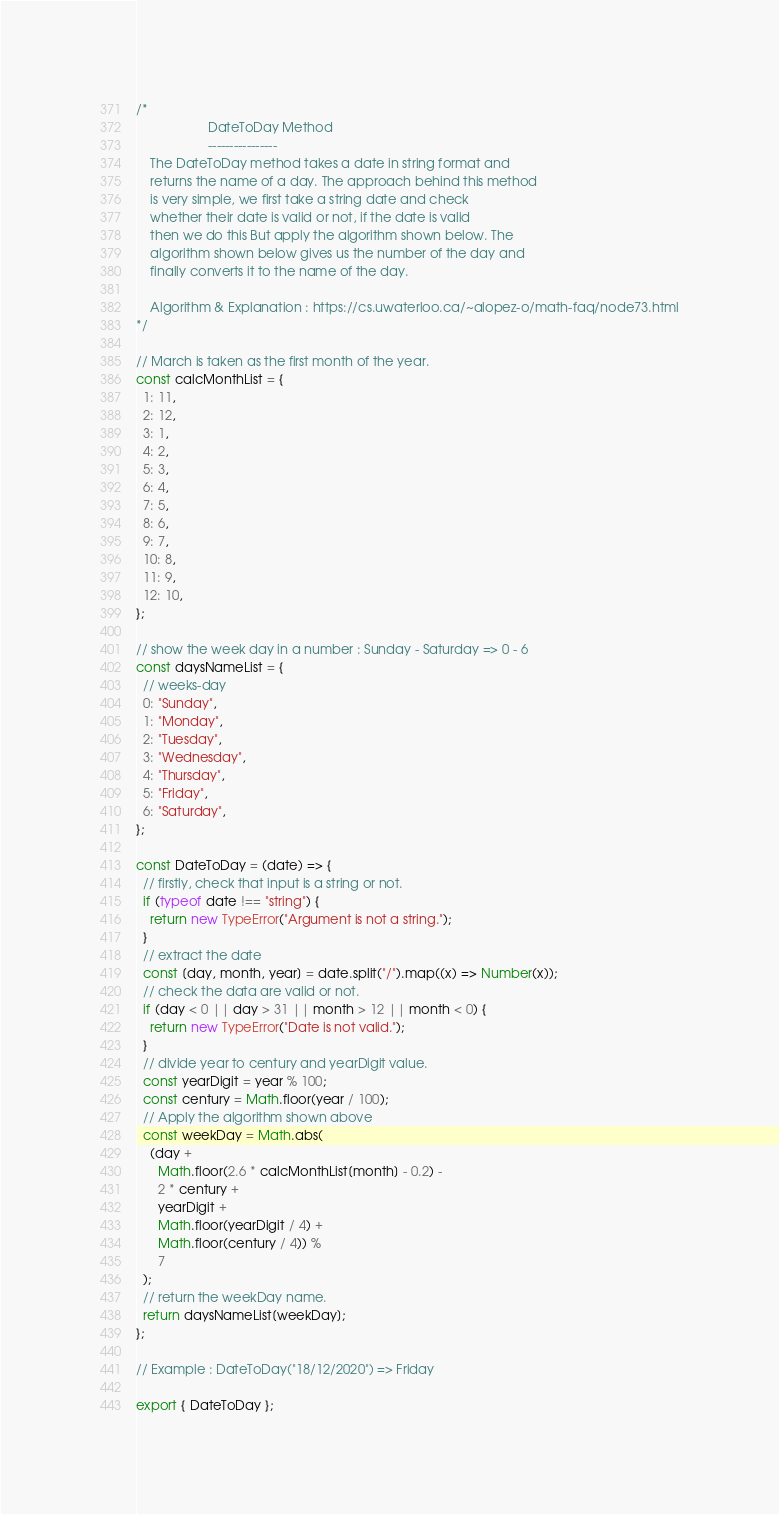<code> <loc_0><loc_0><loc_500><loc_500><_JavaScript_>/*
                    DateToDay Method
                    ----------------
    The DateToDay method takes a date in string format and
    returns the name of a day. The approach behind this method
    is very simple, we first take a string date and check
    whether their date is valid or not, if the date is valid
    then we do this But apply the algorithm shown below. The
    algorithm shown below gives us the number of the day and
    finally converts it to the name of the day.

    Algorithm & Explanation : https://cs.uwaterloo.ca/~alopez-o/math-faq/node73.html
*/

// March is taken as the first month of the year.
const calcMonthList = {
  1: 11,
  2: 12,
  3: 1,
  4: 2,
  5: 3,
  6: 4,
  7: 5,
  8: 6,
  9: 7,
  10: 8,
  11: 9,
  12: 10,
};

// show the week day in a number : Sunday - Saturday => 0 - 6
const daysNameList = {
  // weeks-day
  0: "Sunday",
  1: "Monday",
  2: "Tuesday",
  3: "Wednesday",
  4: "Thursday",
  5: "Friday",
  6: "Saturday",
};

const DateToDay = (date) => {
  // firstly, check that input is a string or not.
  if (typeof date !== "string") {
    return new TypeError("Argument is not a string.");
  }
  // extract the date
  const [day, month, year] = date.split("/").map((x) => Number(x));
  // check the data are valid or not.
  if (day < 0 || day > 31 || month > 12 || month < 0) {
    return new TypeError("Date is not valid.");
  }
  // divide year to century and yearDigit value.
  const yearDigit = year % 100;
  const century = Math.floor(year / 100);
  // Apply the algorithm shown above
  const weekDay = Math.abs(
    (day +
      Math.floor(2.6 * calcMonthList[month] - 0.2) -
      2 * century +
      yearDigit +
      Math.floor(yearDigit / 4) +
      Math.floor(century / 4)) %
      7
  );
  // return the weekDay name.
  return daysNameList[weekDay];
};

// Example : DateToDay("18/12/2020") => Friday

export { DateToDay };
</code> 